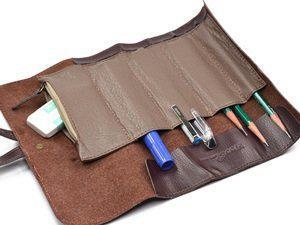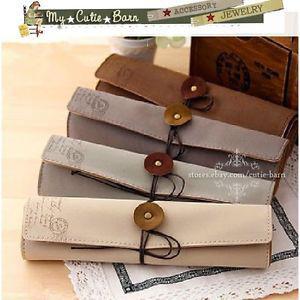The first image is the image on the left, the second image is the image on the right. Considering the images on both sides, is "The left image shows one filled brown leather pencil case opened and right-side up, and the right image contains no more than two pencil cases." valid? Answer yes or no. No. The first image is the image on the left, the second image is the image on the right. Considering the images on both sides, is "there is a brown Swede pencil pouch open and displaying 5 pockets , the pockets have pens and pencils and there is a leather strap attached" valid? Answer yes or no. Yes. 